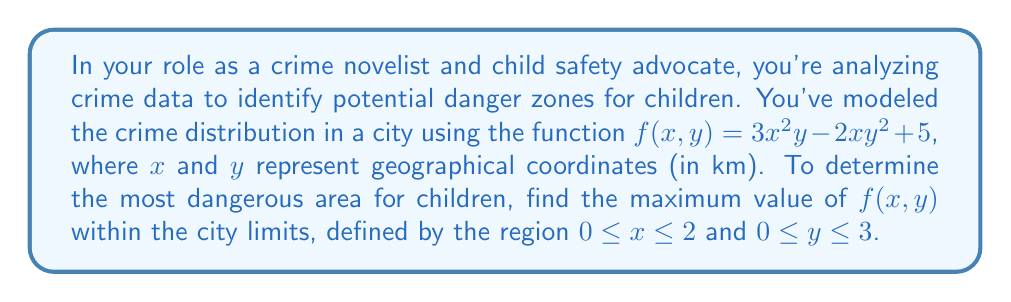Solve this math problem. To find the maximum value of $f(x,y)$ within the given region, we need to follow these steps:

1) Find the critical points inside the region by calculating partial derivatives and setting them to zero:

   $\frac{\partial f}{\partial x} = 6xy - 2y^2 = 0$
   $\frac{\partial f}{\partial y} = 3x^2 - 4xy = 0$

2) Solve the system of equations:
   From the second equation: $3x^2 = 4xy$
   Substitute into the first equation:
   $6xy - 2y^2 = 0$
   $6(\frac{4xy}{3x^2})y - 2y^2 = 0$
   $8y^2 - 2y^2 = 0$
   $6y^2 = 0$
   $y = 0$ (or undefined if $x = 0$)

   Substituting back, we get $x = 0$ (or undefined)

   The only critical point $(0,0)$ is on the boundary.

3) Evaluate $f(x,y)$ at the critical point and all boundary points:

   At $(0,0)$: $f(0,0) = 5$
   Along $x = 0$: $f(0,y) = 5$ for all $y$
   Along $y = 0$: $f(x,0) = 5$ for all $x$
   Along $x = 2$: $f(2,y) = 12y - 8y^2 + 5$
   Along $y = 3$: $f(x,3) = 27x^2 - 18x + 5$

4) Find the maximum values along $x = 2$ and $y = 3$:

   For $f(2,y) = 12y - 8y^2 + 5$:
   $\frac{d}{dy}(12y - 8y^2 + 5) = 12 - 16y = 0$
   $y = \frac{3}{4}$, which is within $[0,3]$
   Maximum value: $f(2,\frac{3}{4}) = 9.5$

   For $f(x,3) = 27x^2 - 18x + 5$:
   $\frac{d}{dx}(27x^2 - 18x + 5) = 54x - 18 = 0$
   $x = \frac{1}{3}$, which is within $[0,2]$
   Maximum value: $f(\frac{1}{3},3) = 7$

5) Compare all maximum values:
   $f(0,0) = f(0,y) = f(x,0) = 5$
   $f(2,\frac{3}{4}) = 9.5$
   $f(\frac{1}{3},3) = 7$

Therefore, the maximum value of $f(x,y)$ in the given region is 9.5, occurring at $(2,\frac{3}{4})$.
Answer: 9.5 at (2, 0.75) 